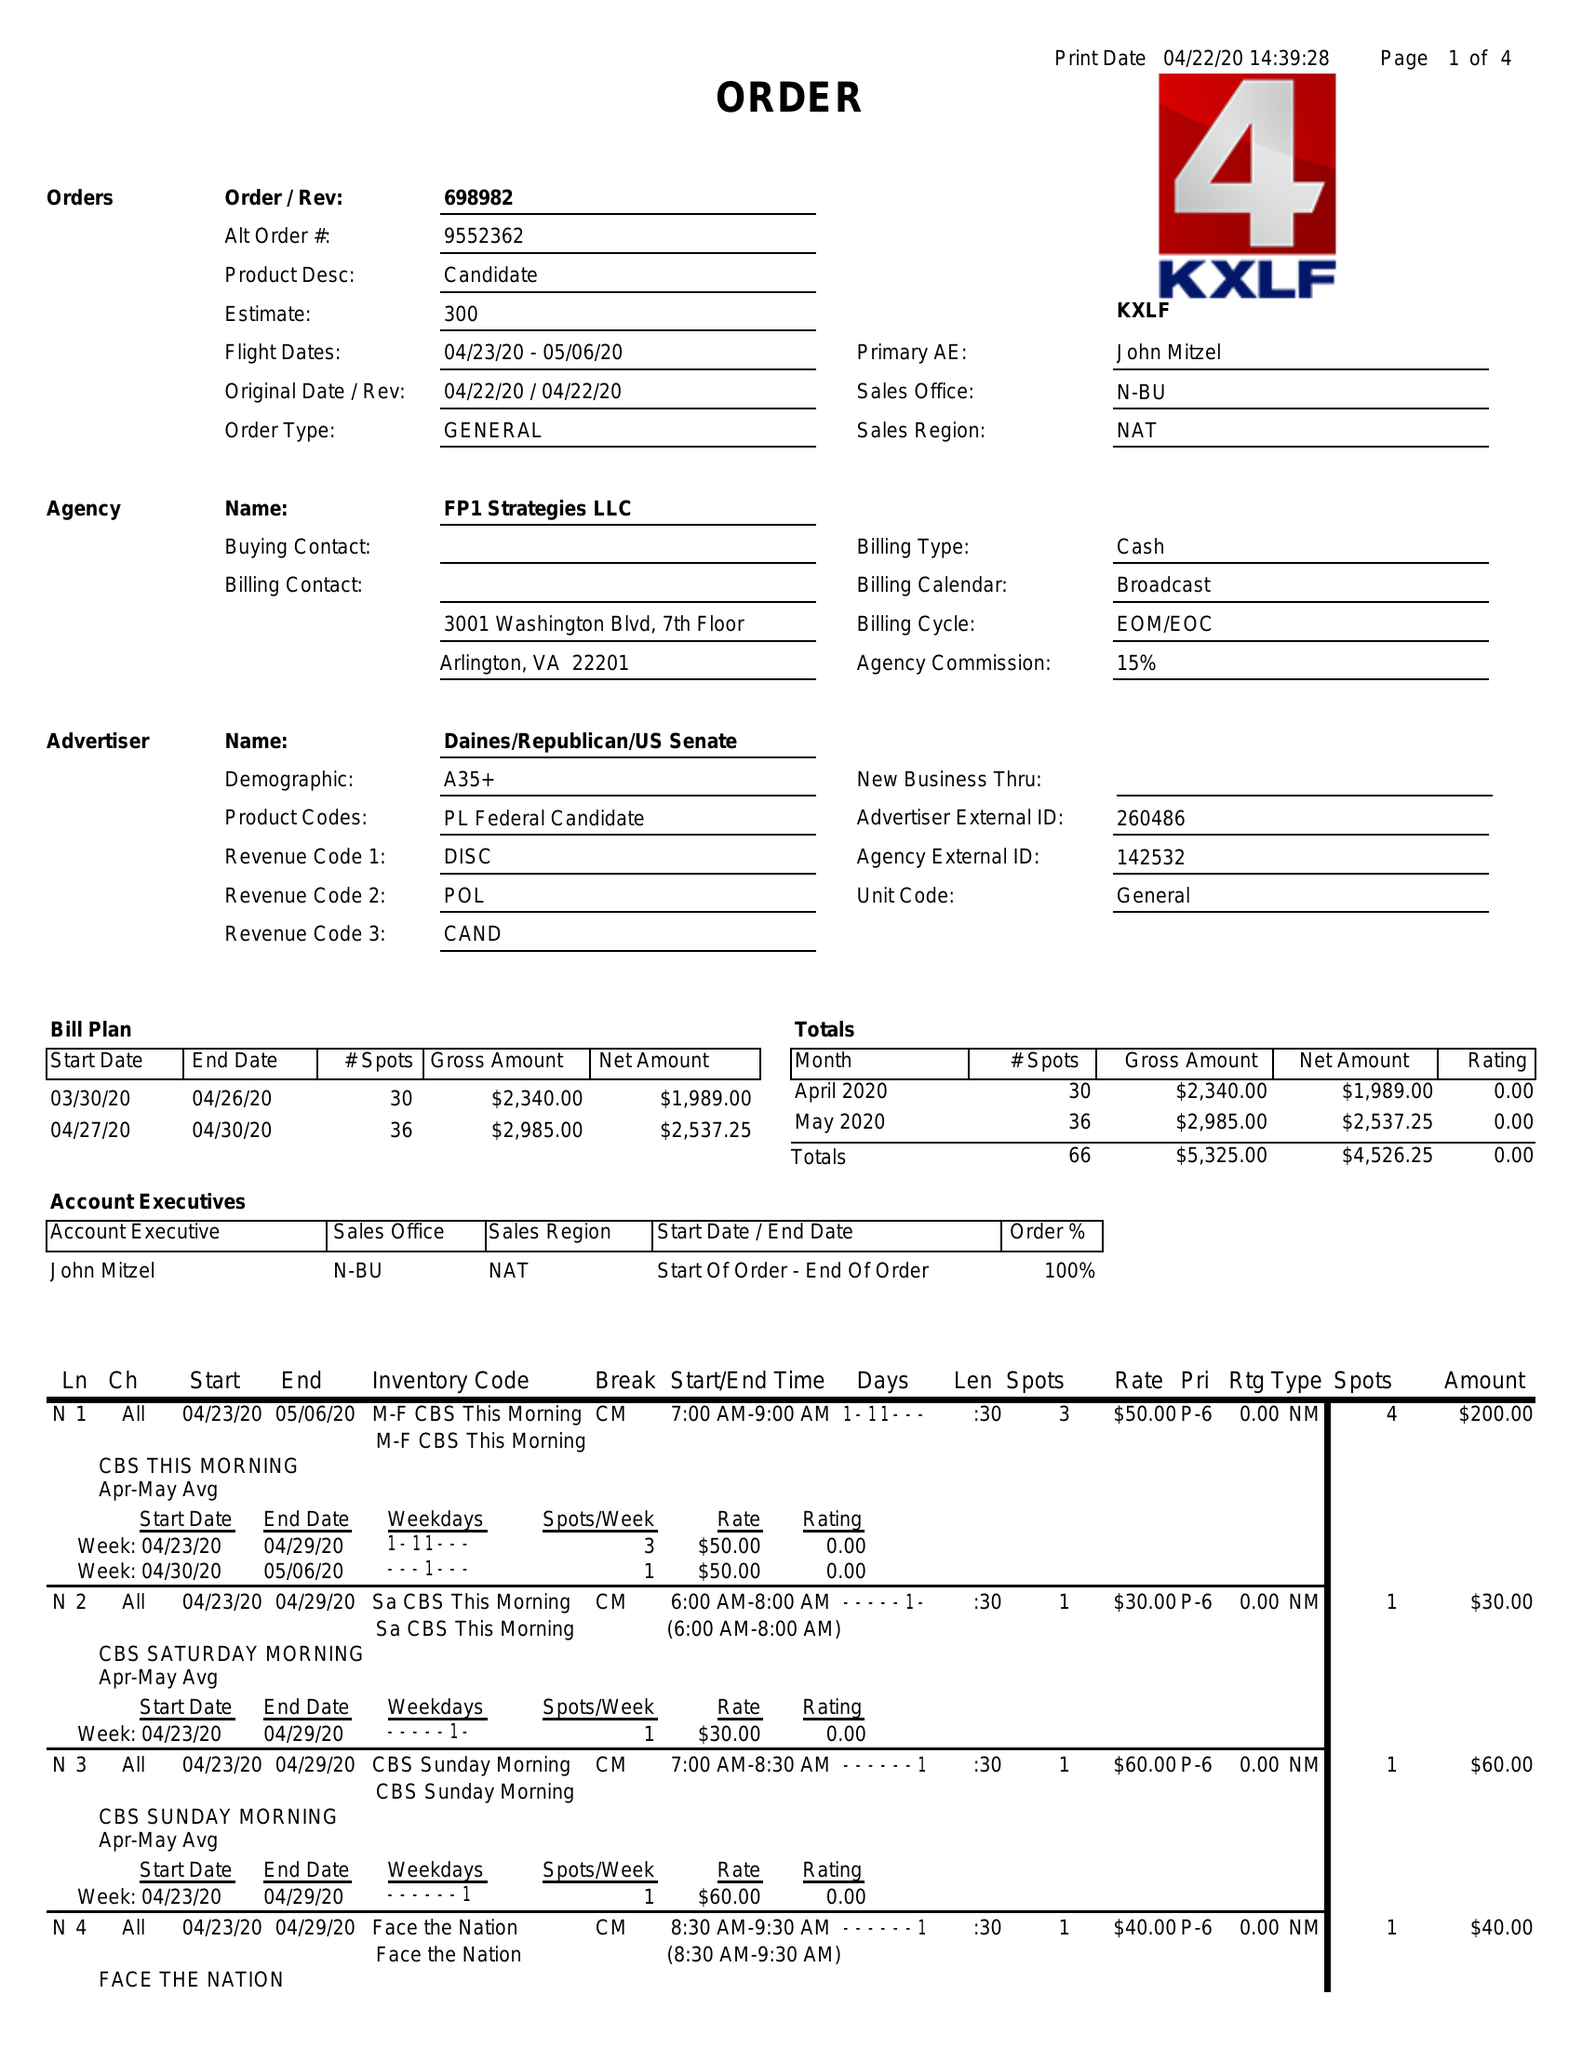What is the value for the gross_amount?
Answer the question using a single word or phrase. 5325.00 